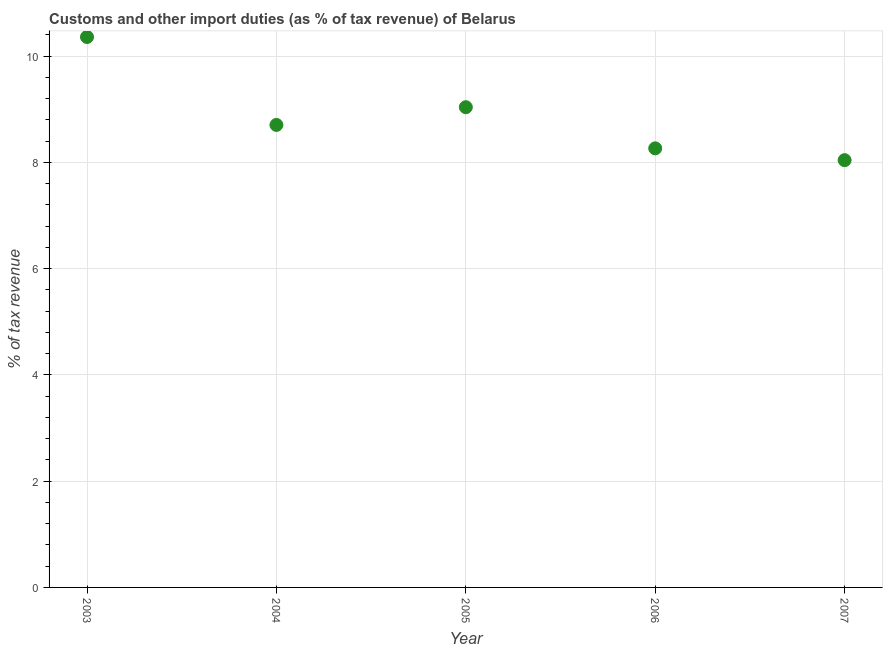What is the customs and other import duties in 2005?
Provide a short and direct response. 9.04. Across all years, what is the maximum customs and other import duties?
Keep it short and to the point. 10.36. Across all years, what is the minimum customs and other import duties?
Provide a short and direct response. 8.04. In which year was the customs and other import duties maximum?
Make the answer very short. 2003. In which year was the customs and other import duties minimum?
Ensure brevity in your answer.  2007. What is the sum of the customs and other import duties?
Make the answer very short. 44.41. What is the difference between the customs and other import duties in 2006 and 2007?
Provide a succinct answer. 0.22. What is the average customs and other import duties per year?
Offer a terse response. 8.88. What is the median customs and other import duties?
Your response must be concise. 8.71. What is the ratio of the customs and other import duties in 2004 to that in 2005?
Give a very brief answer. 0.96. Is the customs and other import duties in 2004 less than that in 2006?
Ensure brevity in your answer.  No. Is the difference between the customs and other import duties in 2003 and 2004 greater than the difference between any two years?
Offer a terse response. No. What is the difference between the highest and the second highest customs and other import duties?
Give a very brief answer. 1.32. What is the difference between the highest and the lowest customs and other import duties?
Give a very brief answer. 2.32. In how many years, is the customs and other import duties greater than the average customs and other import duties taken over all years?
Your response must be concise. 2. How many dotlines are there?
Offer a terse response. 1. What is the difference between two consecutive major ticks on the Y-axis?
Keep it short and to the point. 2. Does the graph contain any zero values?
Make the answer very short. No. What is the title of the graph?
Your response must be concise. Customs and other import duties (as % of tax revenue) of Belarus. What is the label or title of the X-axis?
Offer a very short reply. Year. What is the label or title of the Y-axis?
Give a very brief answer. % of tax revenue. What is the % of tax revenue in 2003?
Make the answer very short. 10.36. What is the % of tax revenue in 2004?
Offer a very short reply. 8.71. What is the % of tax revenue in 2005?
Offer a very short reply. 9.04. What is the % of tax revenue in 2006?
Your answer should be very brief. 8.26. What is the % of tax revenue in 2007?
Give a very brief answer. 8.04. What is the difference between the % of tax revenue in 2003 and 2004?
Offer a very short reply. 1.66. What is the difference between the % of tax revenue in 2003 and 2005?
Ensure brevity in your answer.  1.32. What is the difference between the % of tax revenue in 2003 and 2006?
Make the answer very short. 2.1. What is the difference between the % of tax revenue in 2003 and 2007?
Keep it short and to the point. 2.32. What is the difference between the % of tax revenue in 2004 and 2005?
Your response must be concise. -0.33. What is the difference between the % of tax revenue in 2004 and 2006?
Give a very brief answer. 0.44. What is the difference between the % of tax revenue in 2004 and 2007?
Provide a short and direct response. 0.66. What is the difference between the % of tax revenue in 2005 and 2006?
Offer a very short reply. 0.77. What is the difference between the % of tax revenue in 2005 and 2007?
Your answer should be very brief. 1. What is the difference between the % of tax revenue in 2006 and 2007?
Provide a short and direct response. 0.22. What is the ratio of the % of tax revenue in 2003 to that in 2004?
Ensure brevity in your answer.  1.19. What is the ratio of the % of tax revenue in 2003 to that in 2005?
Ensure brevity in your answer.  1.15. What is the ratio of the % of tax revenue in 2003 to that in 2006?
Provide a succinct answer. 1.25. What is the ratio of the % of tax revenue in 2003 to that in 2007?
Ensure brevity in your answer.  1.29. What is the ratio of the % of tax revenue in 2004 to that in 2006?
Give a very brief answer. 1.05. What is the ratio of the % of tax revenue in 2004 to that in 2007?
Keep it short and to the point. 1.08. What is the ratio of the % of tax revenue in 2005 to that in 2006?
Give a very brief answer. 1.09. What is the ratio of the % of tax revenue in 2005 to that in 2007?
Your answer should be very brief. 1.12. What is the ratio of the % of tax revenue in 2006 to that in 2007?
Make the answer very short. 1.03. 